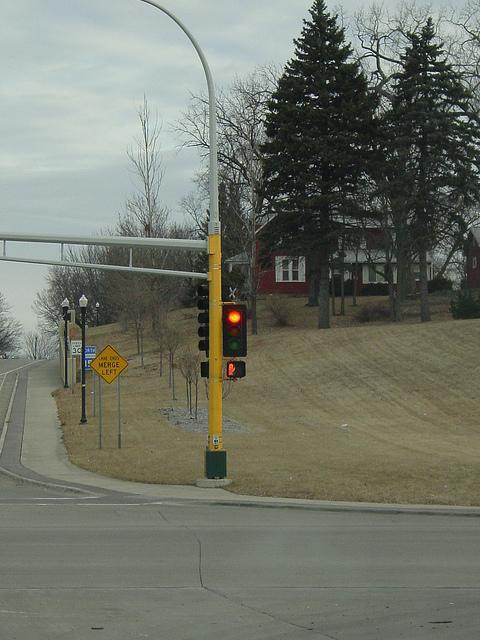How many cars are on the road?
Give a very brief answer. 0. 